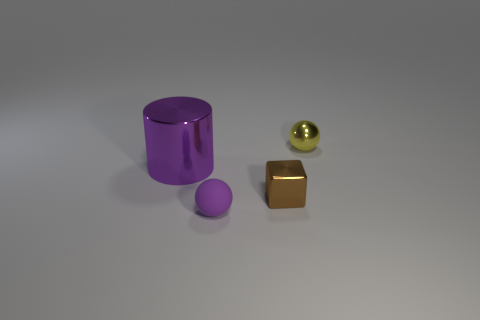Add 4 tiny brown cubes. How many objects exist? 8 Subtract 1 cylinders. How many cylinders are left? 0 Subtract all purple balls. How many balls are left? 1 Subtract 0 gray balls. How many objects are left? 4 Subtract all cylinders. How many objects are left? 3 Subtract all red cubes. Subtract all cyan balls. How many cubes are left? 1 Subtract all brown cylinders. How many purple balls are left? 1 Subtract all purple rubber objects. Subtract all cylinders. How many objects are left? 2 Add 3 small brown objects. How many small brown objects are left? 4 Add 1 small brown cubes. How many small brown cubes exist? 2 